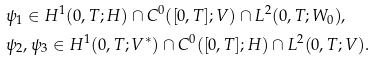Convert formula to latex. <formula><loc_0><loc_0><loc_500><loc_500>& { \psi _ { 1 } \in H ^ { 1 } ( 0 , T ; H ) \cap C ^ { 0 } ( [ 0 , T ] ; V ) \cap L ^ { 2 } ( 0 , T ; W _ { 0 } ) , } \\ & { \psi _ { 2 } , \psi _ { 3 } \in H ^ { 1 } ( 0 , T ; V ^ { * } ) \cap C ^ { 0 } ( [ 0 , T ] ; H ) \cap L ^ { 2 } ( 0 , T ; V ) . }</formula> 